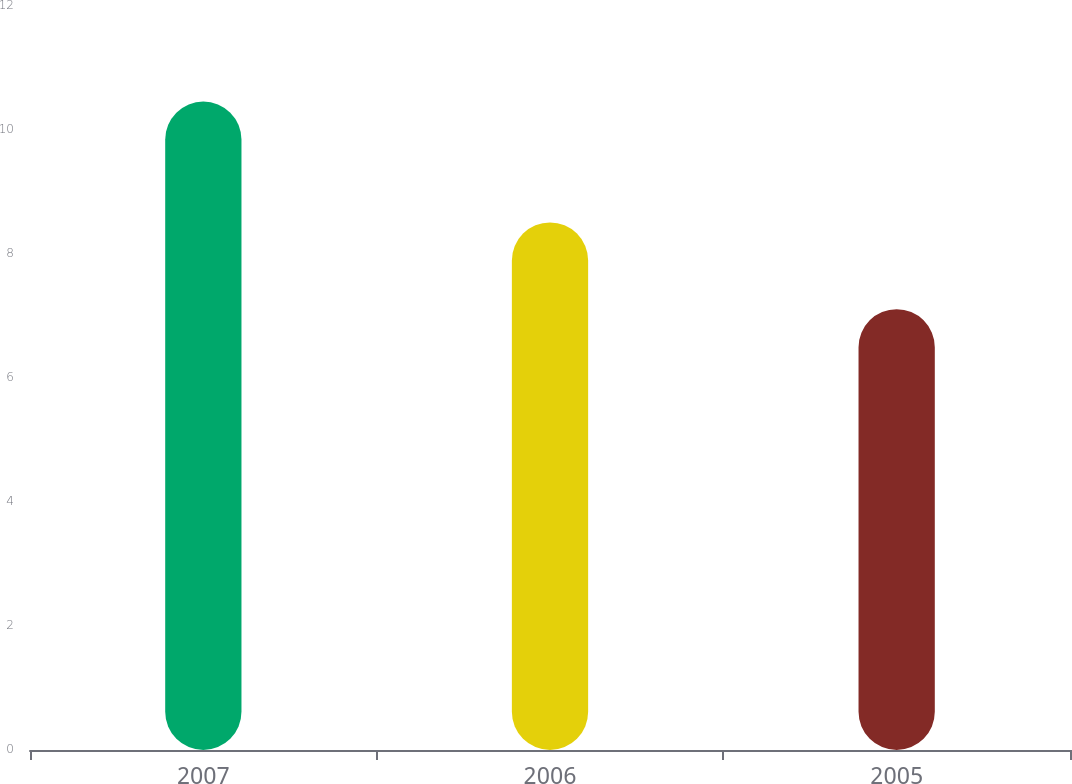<chart> <loc_0><loc_0><loc_500><loc_500><bar_chart><fcel>2007<fcel>2006<fcel>2005<nl><fcel>10.46<fcel>8.51<fcel>7.11<nl></chart> 